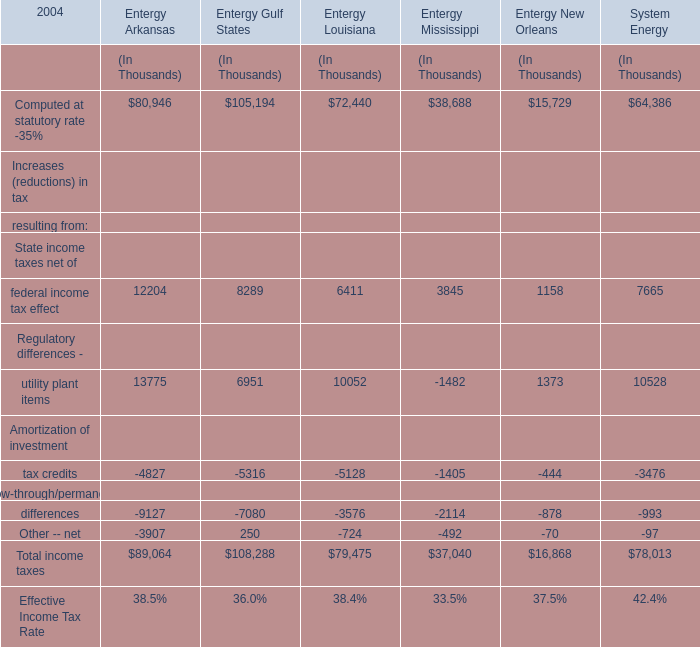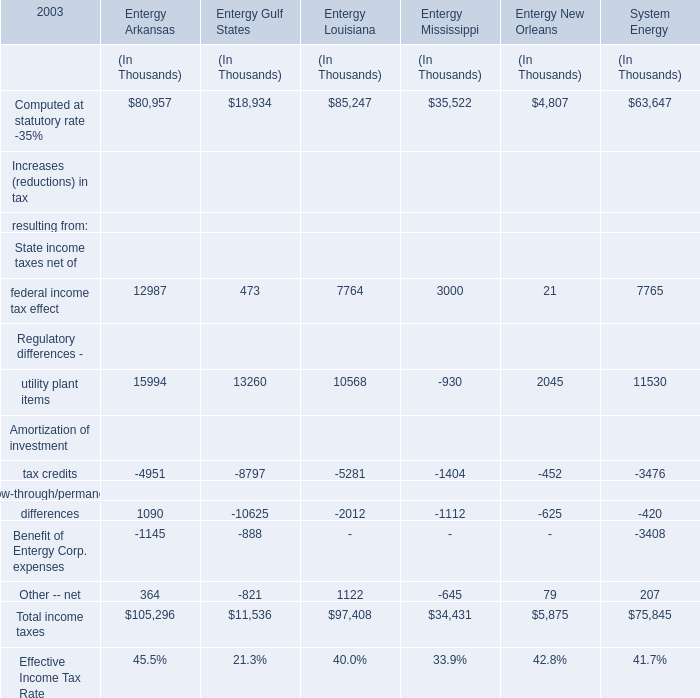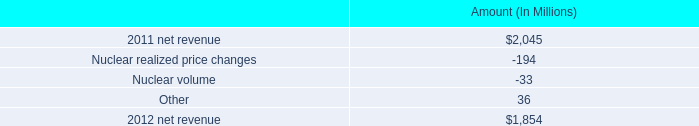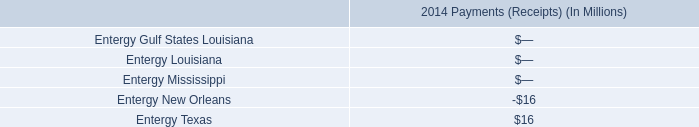What was the average value of State income taxes net of federal income tax effect, Flow-through/permanent differences, Other -- net in 2003 for Entergy Arkansas ? (in Dollars In Thousands) 
Computations: (((12987 + 1090) + 364) / 3)
Answer: 4813.66667. 